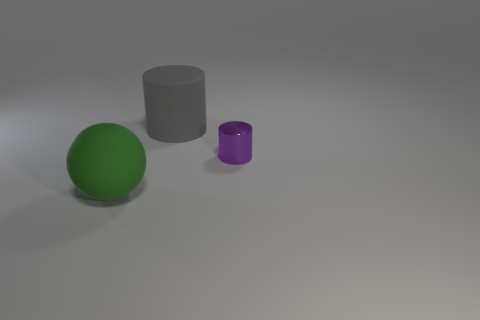Subtract all yellow balls. Subtract all blue cylinders. How many balls are left? 1 Add 1 big gray matte cylinders. How many objects exist? 4 Subtract all spheres. How many objects are left? 2 Add 1 green objects. How many green objects exist? 2 Subtract 0 brown blocks. How many objects are left? 3 Subtract all big green rubber spheres. Subtract all purple metallic things. How many objects are left? 1 Add 2 cylinders. How many cylinders are left? 4 